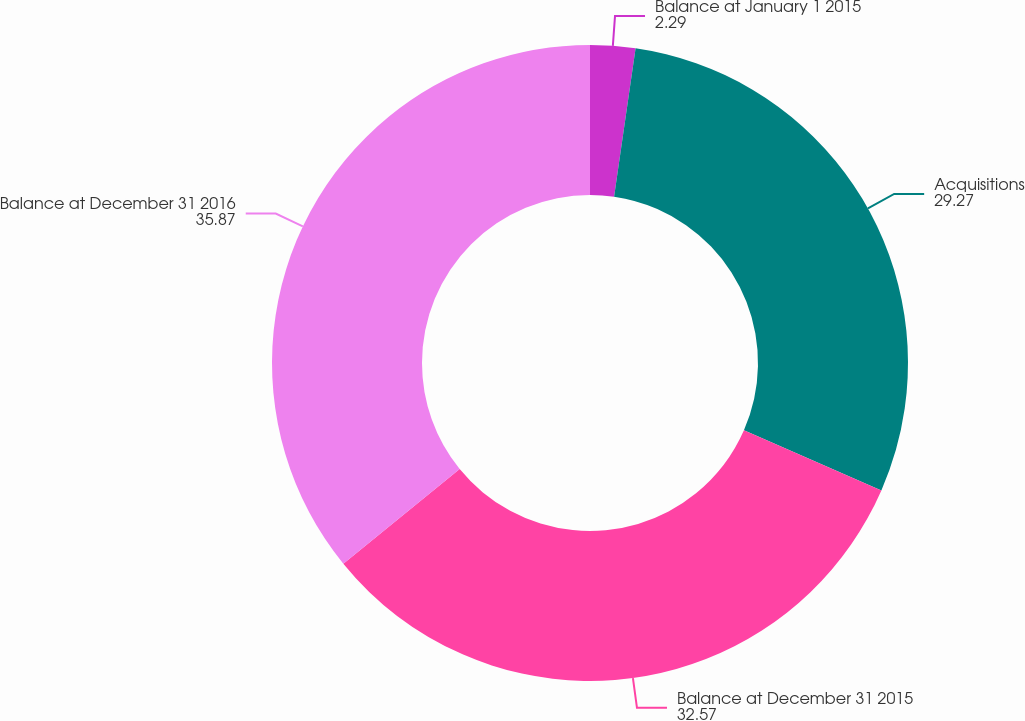<chart> <loc_0><loc_0><loc_500><loc_500><pie_chart><fcel>Balance at January 1 2015<fcel>Acquisitions<fcel>Balance at December 31 2015<fcel>Balance at December 31 2016<nl><fcel>2.29%<fcel>29.27%<fcel>32.57%<fcel>35.87%<nl></chart> 